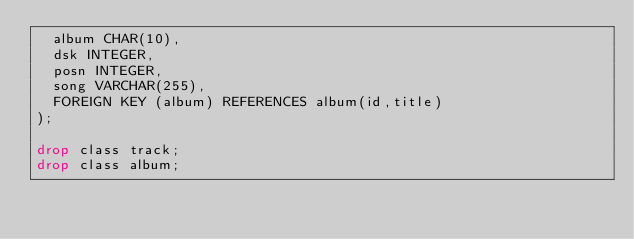Convert code to text. <code><loc_0><loc_0><loc_500><loc_500><_SQL_>  album CHAR(10),
  dsk INTEGER,
  posn INTEGER,
  song VARCHAR(255),
  FOREIGN KEY (album) REFERENCES album(id,title)
);

drop class track;
drop class album;</code> 